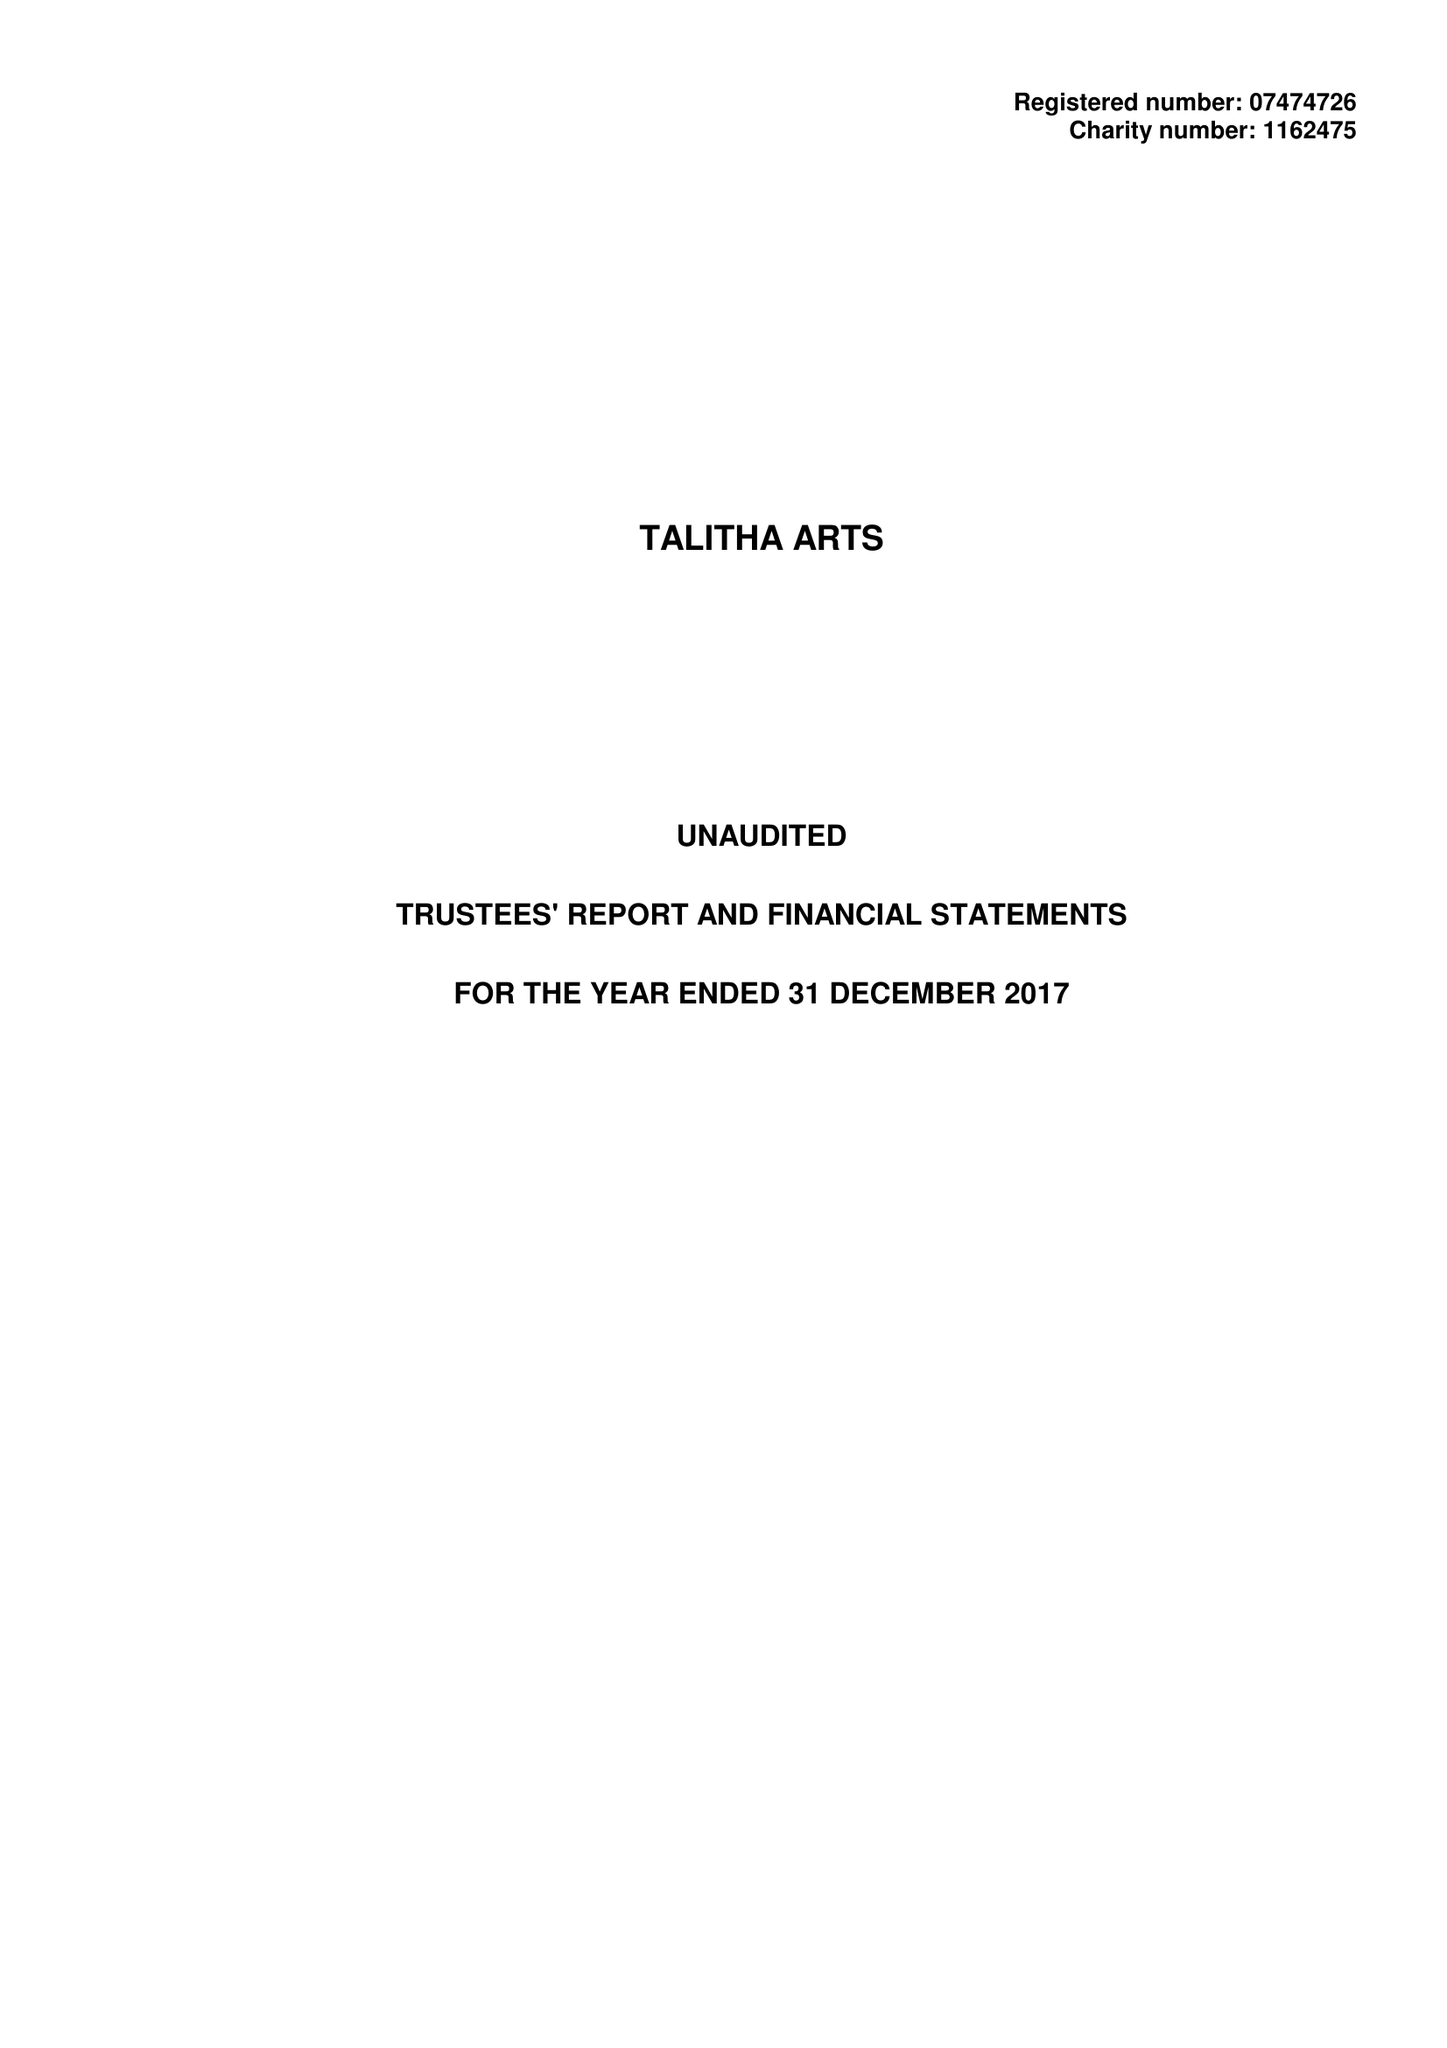What is the value for the spending_annually_in_british_pounds?
Answer the question using a single word or phrase. 61760.00 